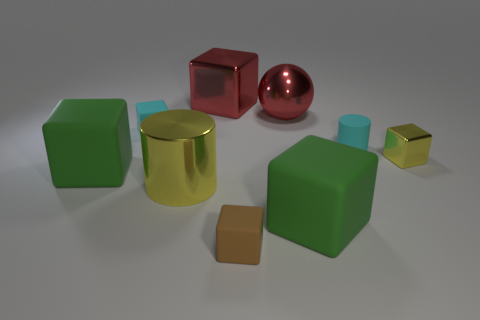Subtract all cyan cylinders. How many green cubes are left? 2 Subtract 4 cubes. How many cubes are left? 2 Subtract all green blocks. How many blocks are left? 4 Subtract all yellow cubes. How many cubes are left? 5 Subtract all cyan cubes. Subtract all purple spheres. How many cubes are left? 5 Add 1 tiny green shiny cubes. How many objects exist? 10 Subtract all cylinders. How many objects are left? 7 Subtract all big brown metallic cylinders. Subtract all small shiny objects. How many objects are left? 8 Add 5 large yellow metallic things. How many large yellow metallic things are left? 6 Add 8 rubber cylinders. How many rubber cylinders exist? 9 